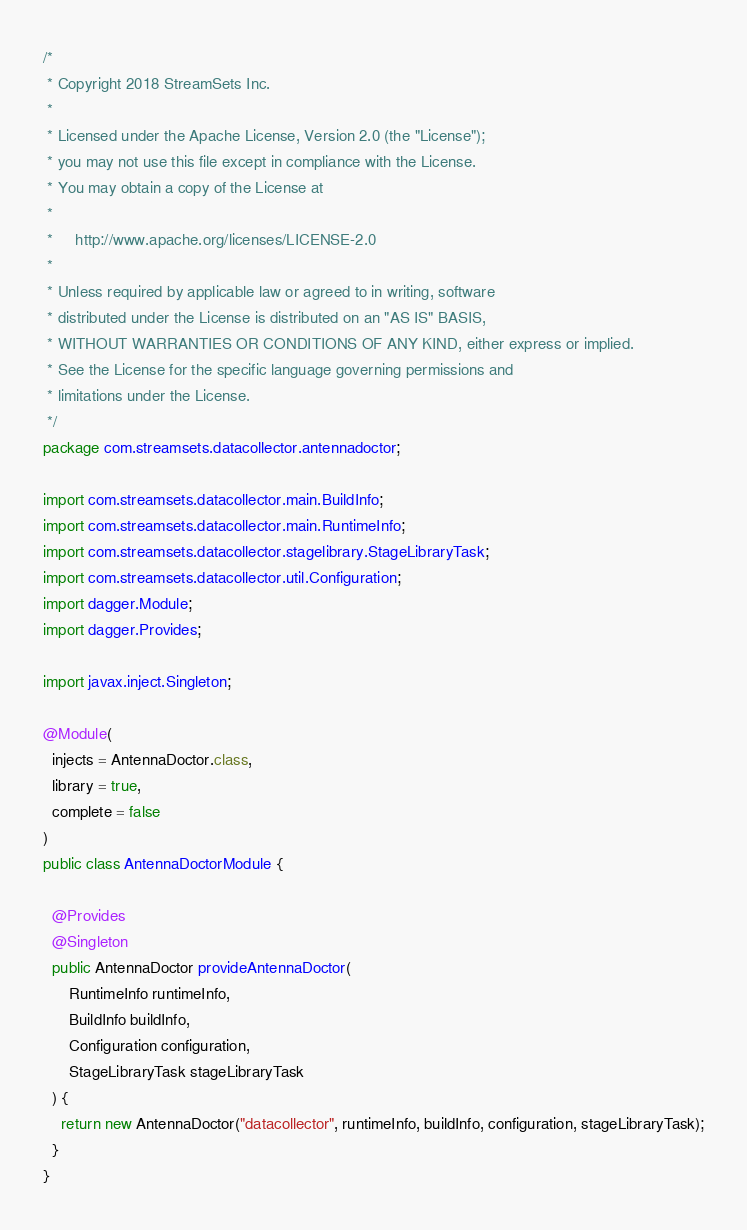Convert code to text. <code><loc_0><loc_0><loc_500><loc_500><_Java_>/*
 * Copyright 2018 StreamSets Inc.
 *
 * Licensed under the Apache License, Version 2.0 (the "License");
 * you may not use this file except in compliance with the License.
 * You may obtain a copy of the License at
 *
 *     http://www.apache.org/licenses/LICENSE-2.0
 *
 * Unless required by applicable law or agreed to in writing, software
 * distributed under the License is distributed on an "AS IS" BASIS,
 * WITHOUT WARRANTIES OR CONDITIONS OF ANY KIND, either express or implied.
 * See the License for the specific language governing permissions and
 * limitations under the License.
 */
package com.streamsets.datacollector.antennadoctor;

import com.streamsets.datacollector.main.BuildInfo;
import com.streamsets.datacollector.main.RuntimeInfo;
import com.streamsets.datacollector.stagelibrary.StageLibraryTask;
import com.streamsets.datacollector.util.Configuration;
import dagger.Module;
import dagger.Provides;

import javax.inject.Singleton;

@Module(
  injects = AntennaDoctor.class,
  library = true,
  complete = false
)
public class AntennaDoctorModule {

  @Provides
  @Singleton
  public AntennaDoctor provideAntennaDoctor(
      RuntimeInfo runtimeInfo,
      BuildInfo buildInfo,
      Configuration configuration,
      StageLibraryTask stageLibraryTask
  ) {
    return new AntennaDoctor("datacollector", runtimeInfo, buildInfo, configuration, stageLibraryTask);
  }
}
</code> 